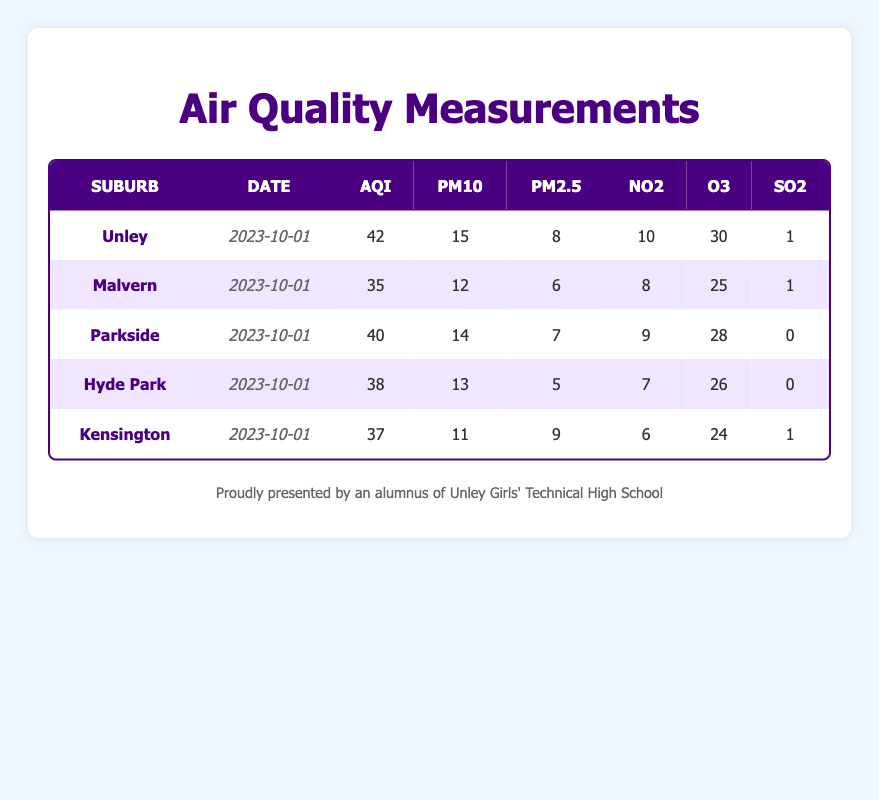What is the Air Quality Index (AQI) for Unley? The AQI for Unley is explicitly listed in the table under the corresponding suburb and date. It shows a value of 42.
Answer: 42 Which suburb has the highest level of PM10 on the given date? By reviewing the PM10 column, we can see that Unley has the highest PM10 value of 15 compared to the other suburbs listed.
Answer: Unley What is the average AQI of all the suburbs provided? First, sum the AQI values: 42 + 35 + 40 + 38 + 37 = 192. Then, divide by the number of suburbs, which is 5. So, 192/5 = 38.4.
Answer: 38.4 Does Hyde Park have a higher AQI than Kensington? Comparing the AQI values for Hyde Park (38) and Kensington (37) in the table, we see that Hyde Park has a higher AQI.
Answer: Yes What is the difference between the PM2.5 levels of Malvern and Parkside? The PM2.5 level for Malvern is 6 and for Parkside is 7. To find the difference, subtract: 7 - 6 = 1.
Answer: 1 Which suburb recorded a SO2 level of 0? By examining the SO2 column, we find that both Parkside and Hyde Park have a SO2 value of 0.
Answer: Parkside and Hyde Park What is the total NO2 level across all suburbs? We add the NO2 levels of all suburbs: 10 (Unley) + 8 (Malvern) + 9 (Parkside) + 7 (Hyde Park) + 6 (Kensington) = 40.
Answer: 40 Which suburb has the lowest AQI reading? By comparing the AQI values listed in the table, Malvern has the lowest reading at 35.
Answer: Malvern Is the O3 level in Kensington higher than that in Parkside? Looking at the values, Kensington shows an O3 level of 24 while Parkside has 28. Since 24 is not higher than 28, the answer is no.
Answer: No 